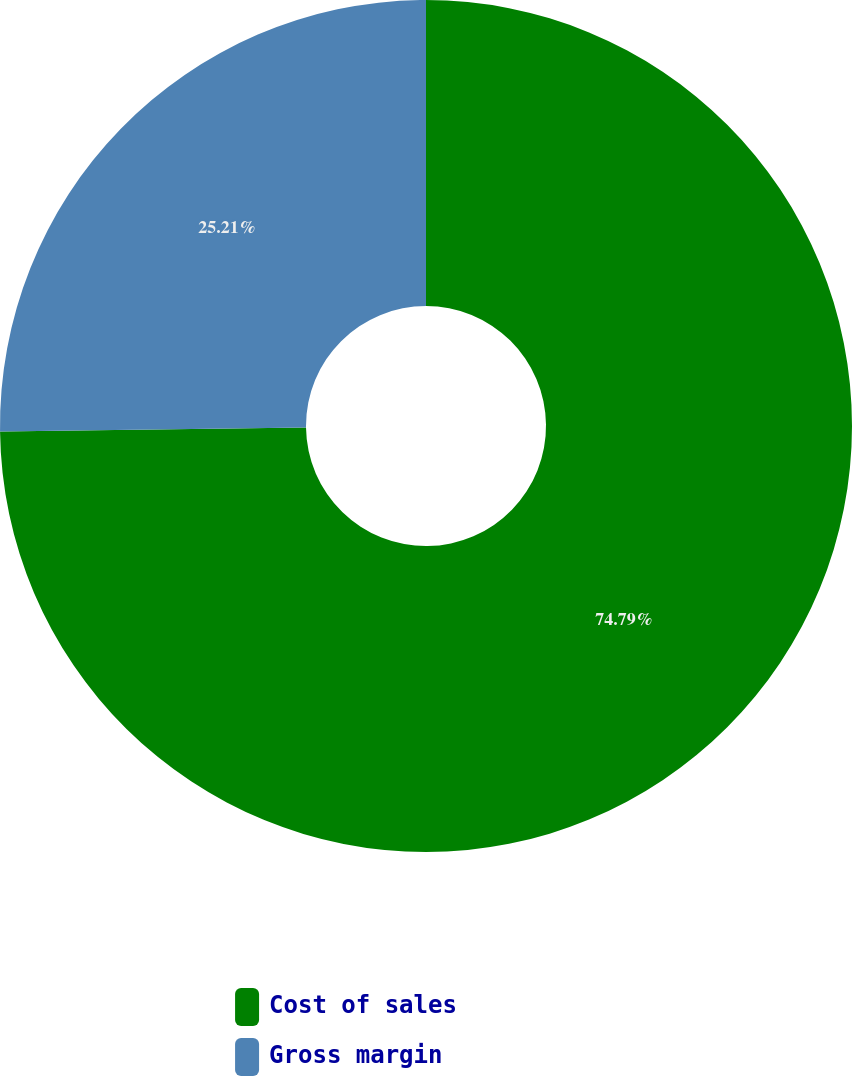<chart> <loc_0><loc_0><loc_500><loc_500><pie_chart><fcel>Cost of sales<fcel>Gross margin<nl><fcel>74.79%<fcel>25.21%<nl></chart> 